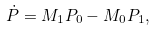Convert formula to latex. <formula><loc_0><loc_0><loc_500><loc_500>\dot { P } = M _ { 1 } P _ { 0 } - M _ { 0 } P _ { 1 } ,</formula> 